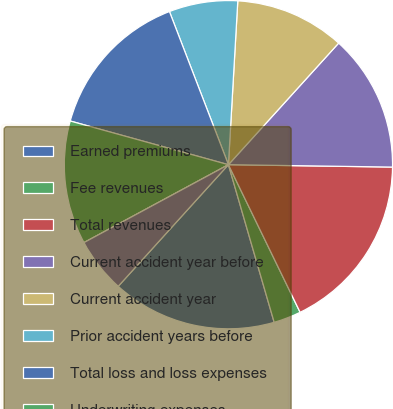<chart> <loc_0><loc_0><loc_500><loc_500><pie_chart><fcel>Earned premiums<fcel>Fee revenues<fcel>Total revenues<fcel>Current accident year before<fcel>Current accident year<fcel>Prior accident years before<fcel>Total loss and loss expenses<fcel>Underwriting expenses<fcel>Prior accident years<fcel>Total loss and loss expense<nl><fcel>16.21%<fcel>2.7%<fcel>17.57%<fcel>13.51%<fcel>10.81%<fcel>6.76%<fcel>14.86%<fcel>12.16%<fcel>0.0%<fcel>5.41%<nl></chart> 